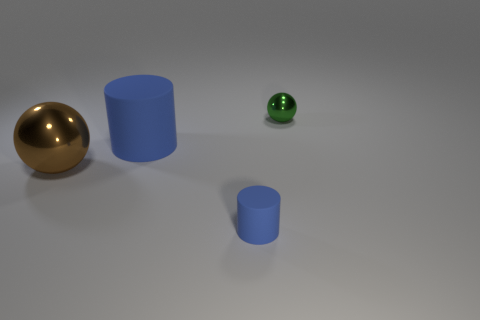How would you describe the composition and balance of the image? The composition is clean and minimalistic, with the objects staggered in size and placement, creating a sense of depth. The larger objects are closer, while the tiny cylinder is farther away, contributing to a balanced distribution of visual weight across the scene. 